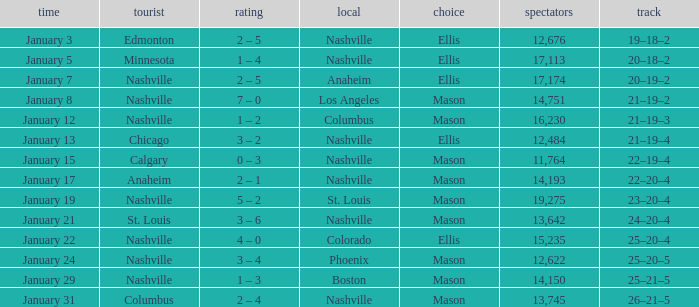On January 15, what was the most in attendance? 11764.0. 